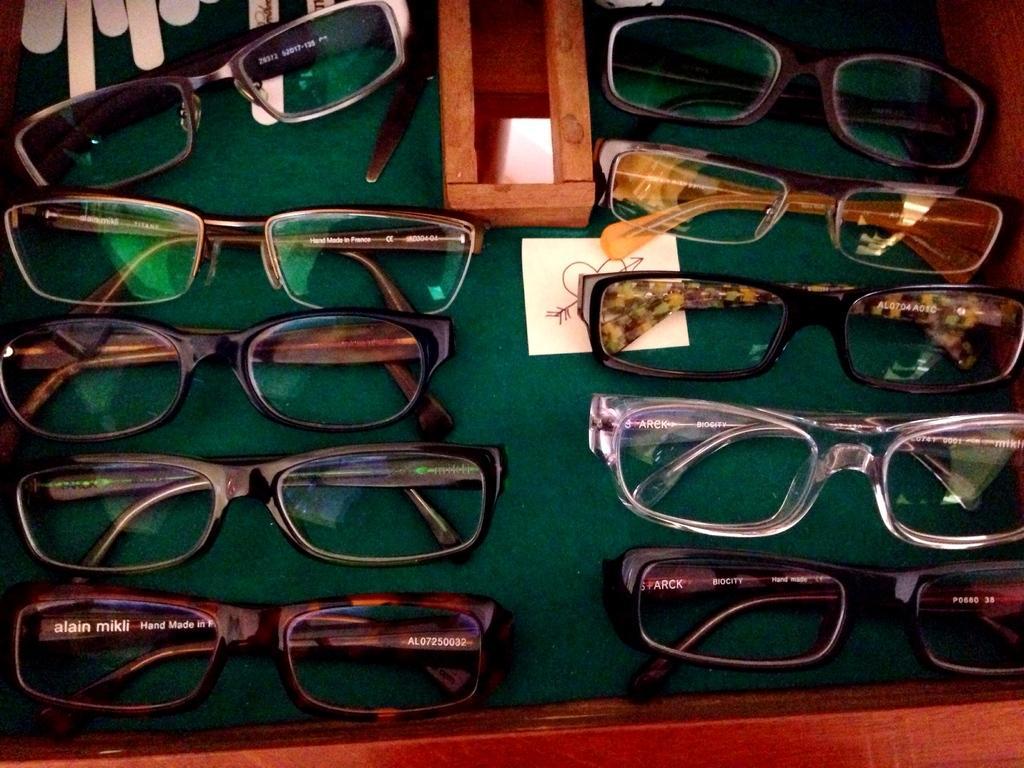Can you describe this image briefly? In this image there are tables, on that table there are spectacles. 